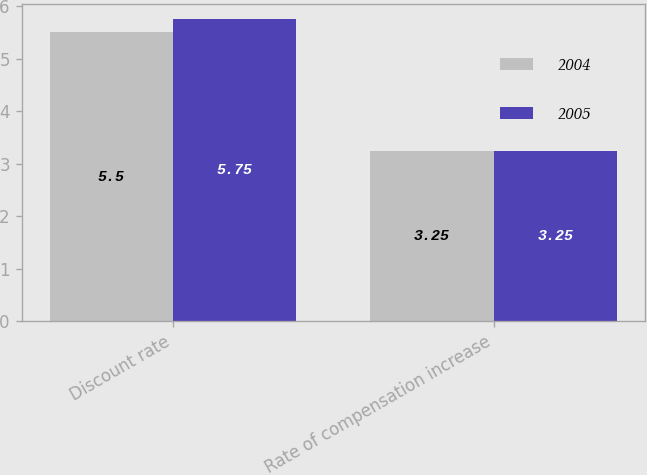Convert chart. <chart><loc_0><loc_0><loc_500><loc_500><stacked_bar_chart><ecel><fcel>Discount rate<fcel>Rate of compensation increase<nl><fcel>2004<fcel>5.5<fcel>3.25<nl><fcel>2005<fcel>5.75<fcel>3.25<nl></chart> 